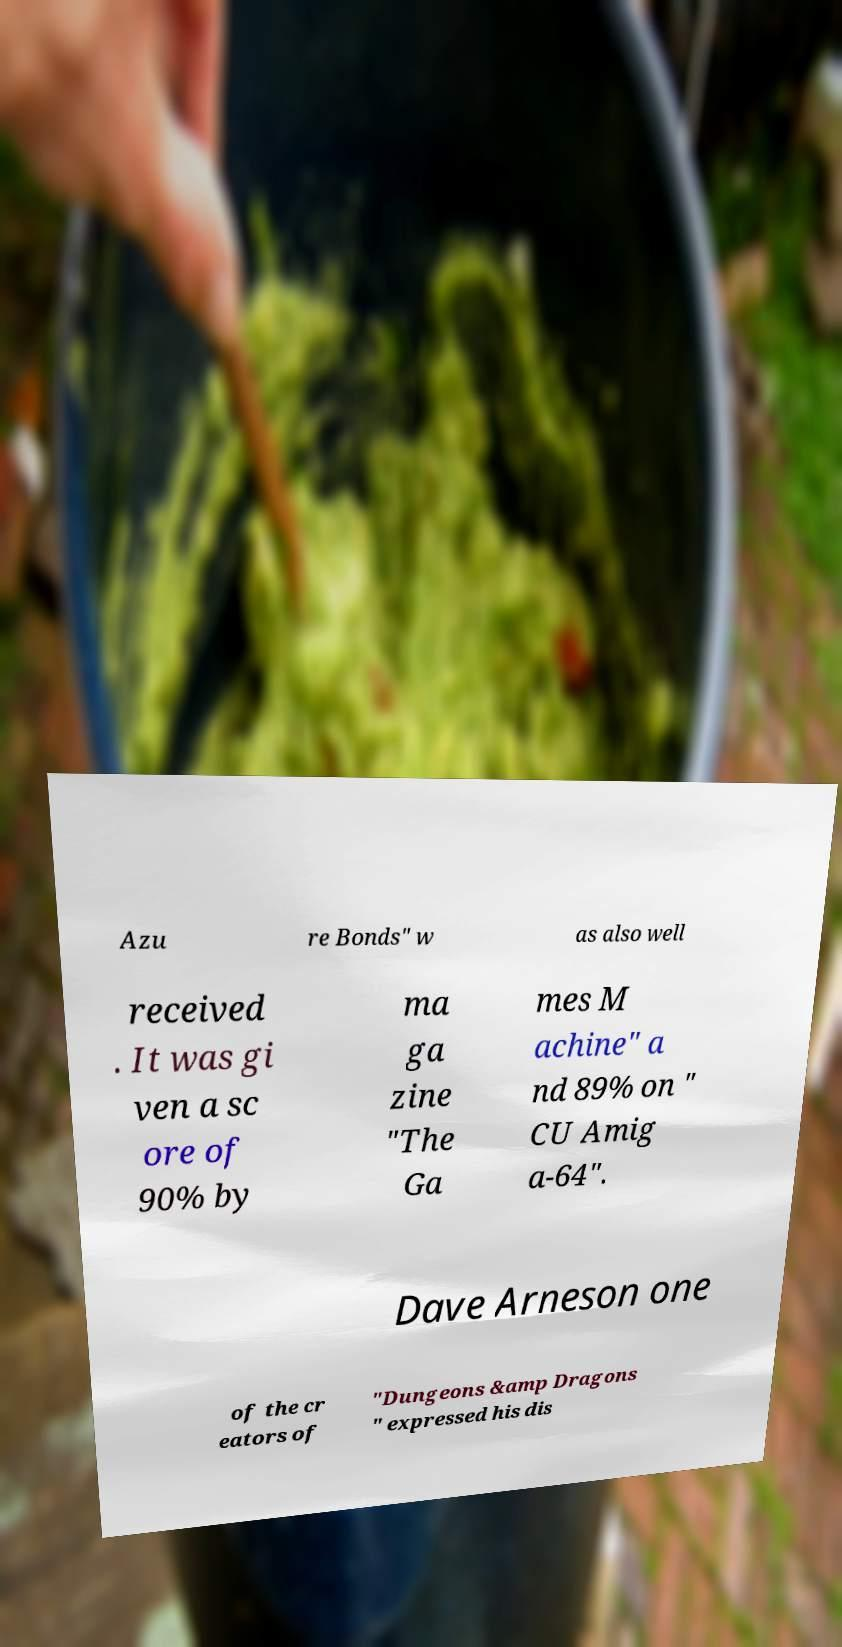For documentation purposes, I need the text within this image transcribed. Could you provide that? Azu re Bonds" w as also well received . It was gi ven a sc ore of 90% by ma ga zine "The Ga mes M achine" a nd 89% on " CU Amig a-64". Dave Arneson one of the cr eators of "Dungeons &amp Dragons " expressed his dis 